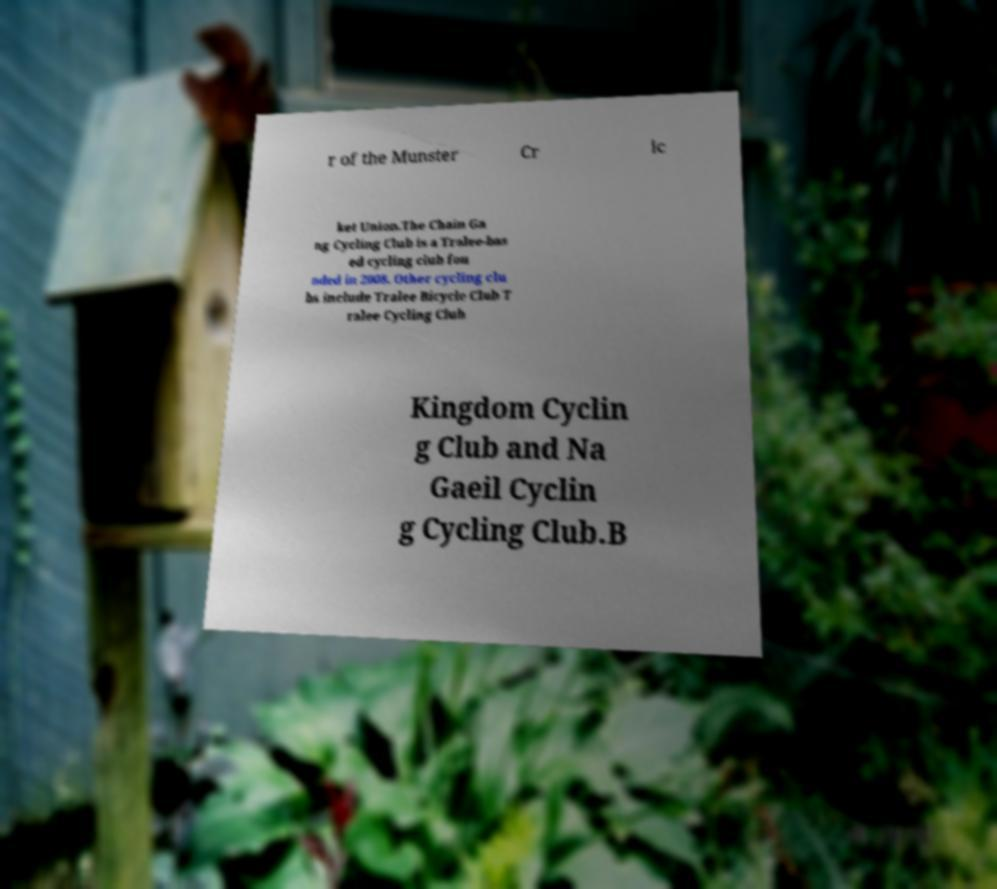Can you accurately transcribe the text from the provided image for me? r of the Munster Cr ic ket Union.The Chain Ga ng Cycling Club is a Tralee-bas ed cycling club fou nded in 2008. Other cycling clu bs include Tralee Bicycle Club T ralee Cycling Club Kingdom Cyclin g Club and Na Gaeil Cyclin g Cycling Club.B 